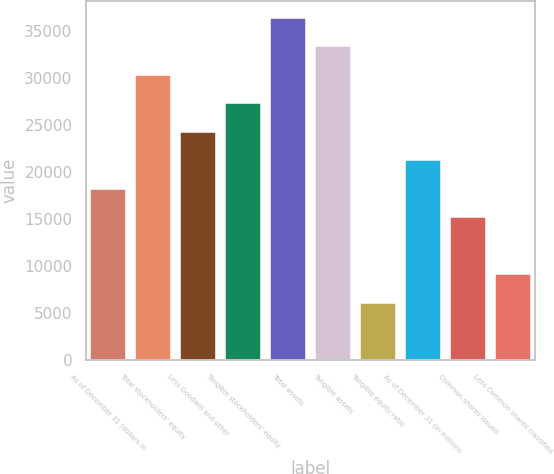<chart> <loc_0><loc_0><loc_500><loc_500><bar_chart><fcel>As of December 31 (dollars in<fcel>Total stockholders' equity<fcel>Less Goodwill and other<fcel>Tangible stockholders' equity<fcel>Total assets<fcel>Tangible assets<fcel>Tangible equity ratio<fcel>As of December 31 (in millions<fcel>Common shares issued<fcel>Less Common shares classified<nl><fcel>18197.7<fcel>30324<fcel>24260.8<fcel>27292.4<fcel>36387.1<fcel>33355.5<fcel>6071.48<fcel>21229.3<fcel>15166.2<fcel>9103.04<nl></chart> 